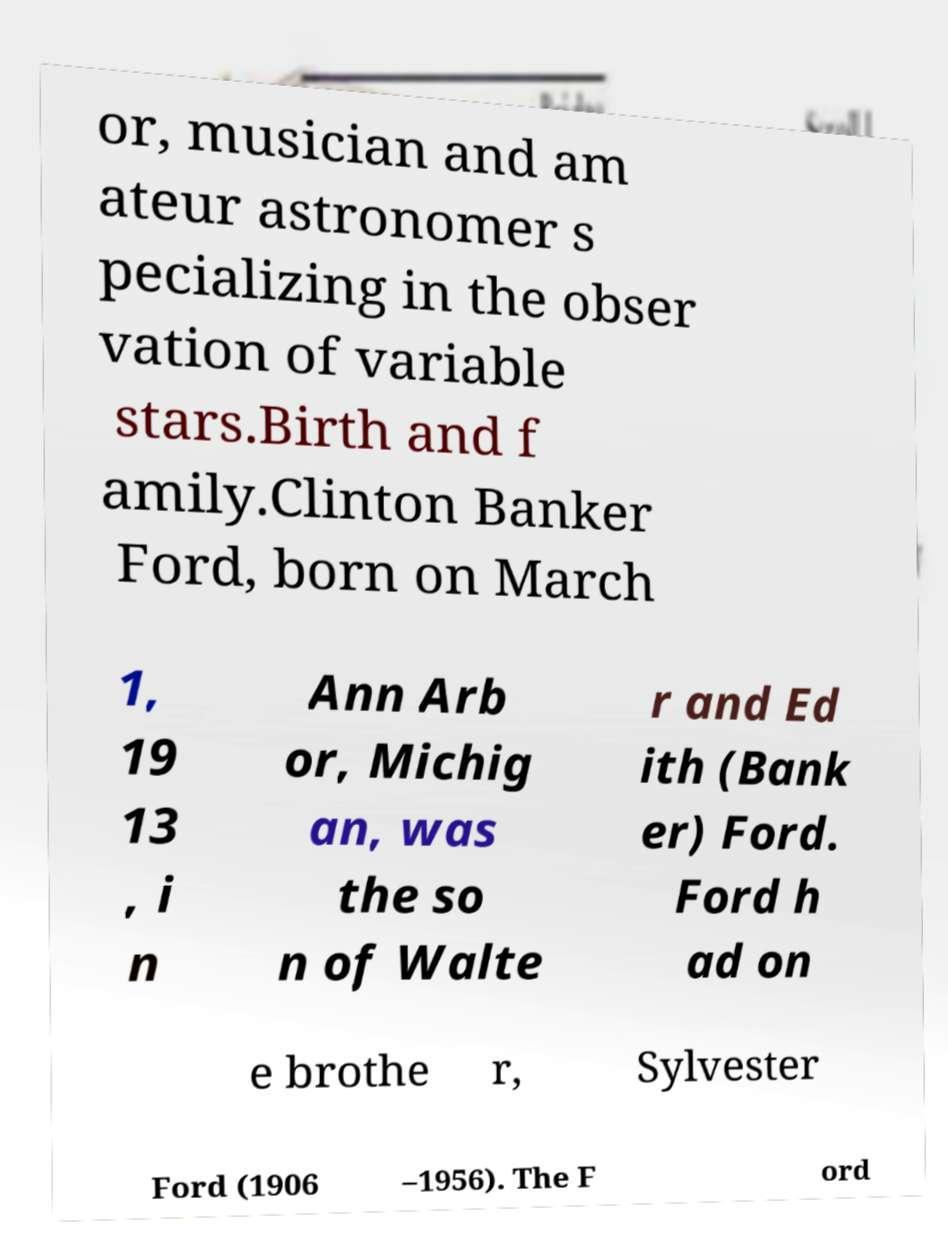Could you assist in decoding the text presented in this image and type it out clearly? or, musician and am ateur astronomer s pecializing in the obser vation of variable stars.Birth and f amily.Clinton Banker Ford, born on March 1, 19 13 , i n Ann Arb or, Michig an, was the so n of Walte r and Ed ith (Bank er) Ford. Ford h ad on e brothe r, Sylvester Ford (1906 –1956). The F ord 